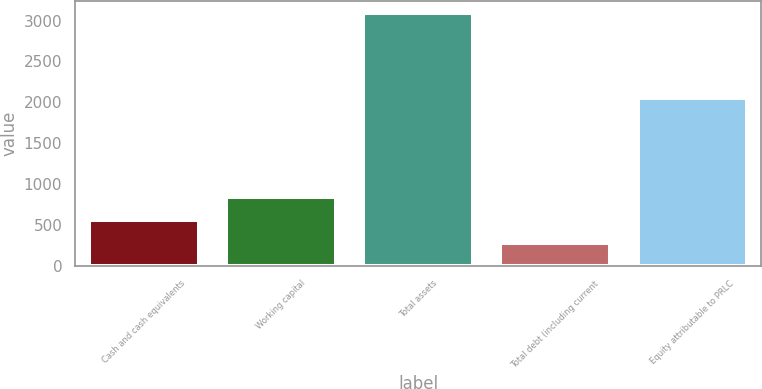Convert chart. <chart><loc_0><loc_0><loc_500><loc_500><bar_chart><fcel>Cash and cash equivalents<fcel>Working capital<fcel>Total assets<fcel>Total debt (including current<fcel>Equity attributable to PRLC<nl><fcel>561.23<fcel>842.06<fcel>3088.7<fcel>280.4<fcel>2049.6<nl></chart> 